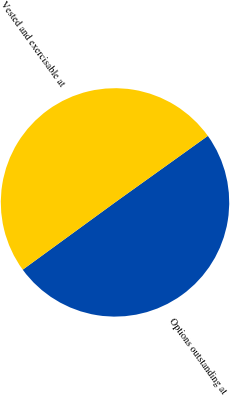Convert chart to OTSL. <chart><loc_0><loc_0><loc_500><loc_500><pie_chart><fcel>Options outstanding at<fcel>Vested and exercisable at<nl><fcel>49.87%<fcel>50.13%<nl></chart> 